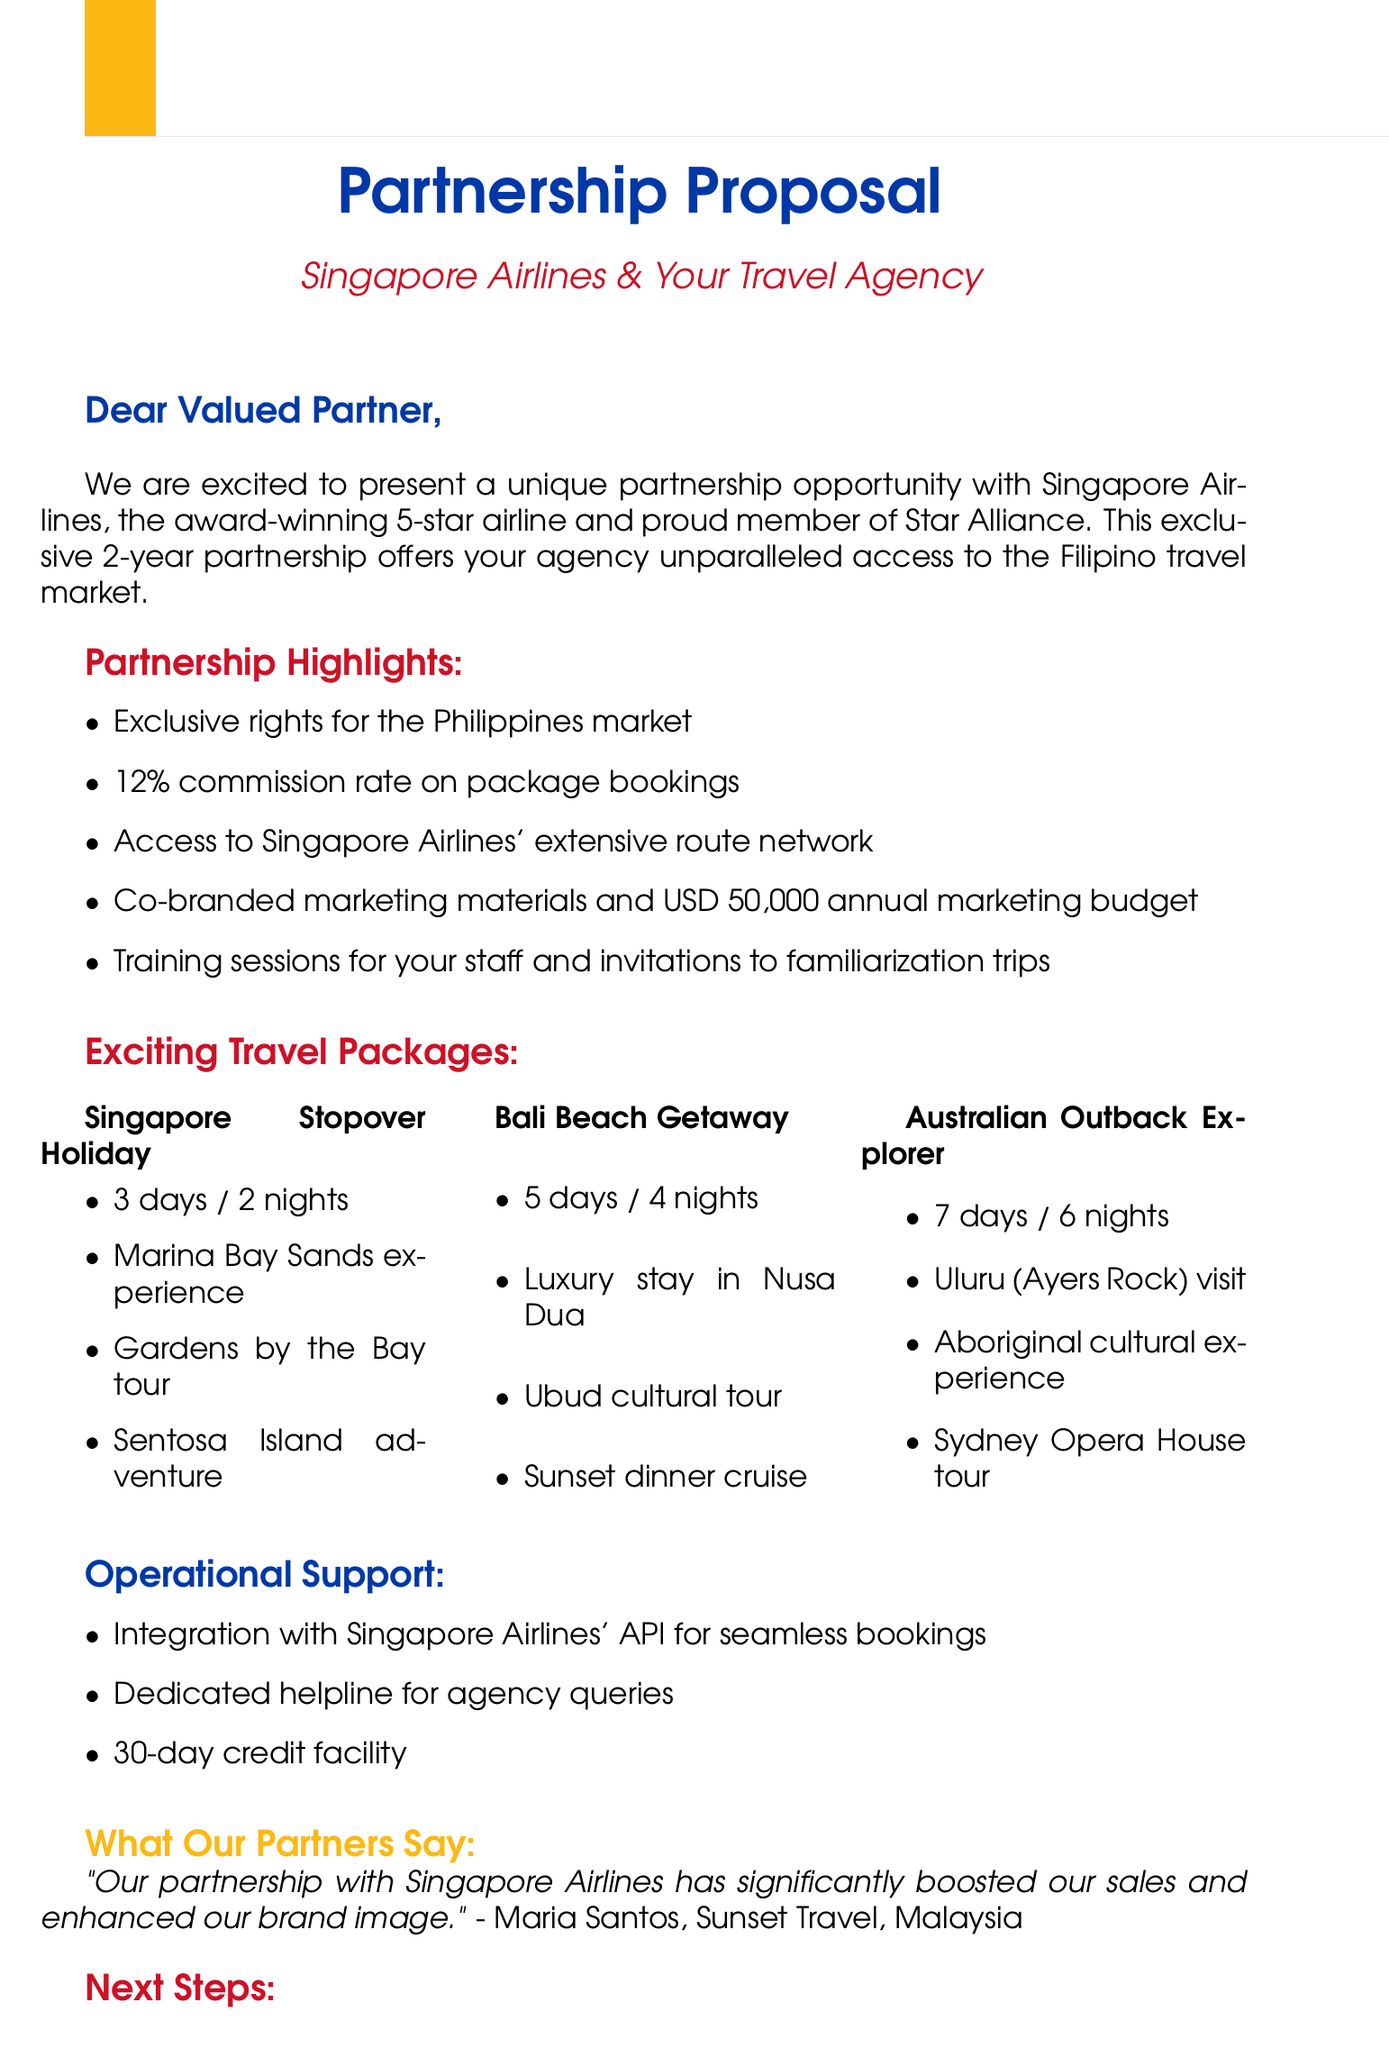What is the name of the airline? The name of the airline mentioned in the document is Singapore Airlines.
Answer: Singapore Airlines What is the commission rate for the partnership? The commission rate outlined in the document for the partnership is 12 percent.
Answer: 12% How long is the proposed partnership duration? The duration of the partnership as stated in the document is 2 years.
Answer: 2 years What is one of the primary target markets? The primary target market identified in the document is Filipino leisure travelers.
Answer: Filipino leisure travelers What is one travel package included in the proposal? The document lists multiple travel packages; one of them is Singapore Stopover Holiday.
Answer: Singapore Stopover Holiday What annual marketing budget is allocated for the partnership? The annual marketing budget for the partnership mentioned in the document is USD 50,000.
Answer: USD 50,000 What is a specific benefit provided to the agency? One of the benefits for the agency is access to Singapore Airlines' extensive route network.
Answer: Access to Singapore Airlines' extensive route network Which travel package includes a cultural tour? The Bali Beach Getaway package includes a cultural tour in Ubud.
Answer: Bali Beach Getaway What is the next step mentioned in the proposal? The next step outlined in the proposal is to review the proposal itself.
Answer: Review proposal 